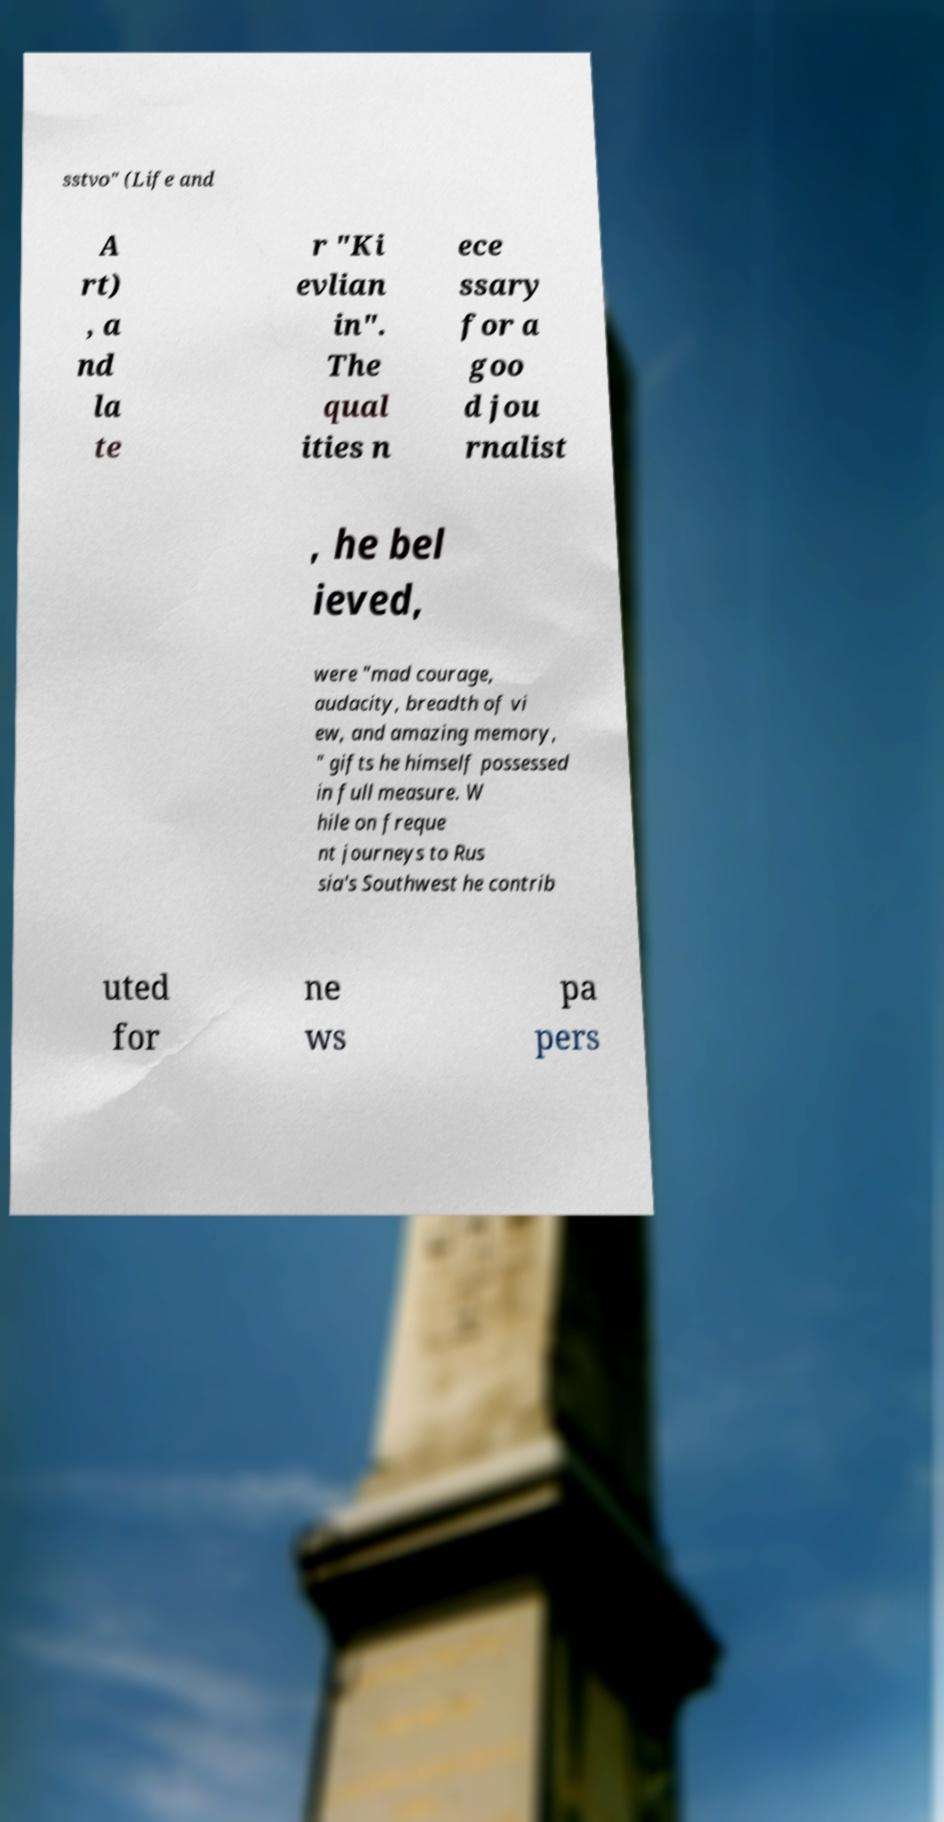Can you accurately transcribe the text from the provided image for me? sstvo" (Life and A rt) , a nd la te r "Ki evlian in". The qual ities n ece ssary for a goo d jou rnalist , he bel ieved, were "mad courage, audacity, breadth of vi ew, and amazing memory, " gifts he himself possessed in full measure. W hile on freque nt journeys to Rus sia's Southwest he contrib uted for ne ws pa pers 